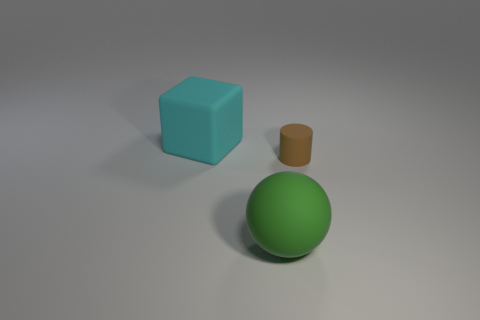Are there an equal number of cyan matte cubes to the right of the tiny matte thing and gray balls?
Keep it short and to the point. Yes. What shape is the matte object that is to the right of the big cube and to the left of the brown cylinder?
Your answer should be very brief. Sphere. Do the green rubber ball and the brown cylinder have the same size?
Your response must be concise. No. Is there a big green cube made of the same material as the green sphere?
Provide a short and direct response. No. What number of big things are both behind the brown matte thing and in front of the brown cylinder?
Offer a very short reply. 0. There is a brown cylinder that is the same material as the large ball; what size is it?
Provide a short and direct response. Small. What number of objects are tiny blue rubber spheres or rubber objects?
Your answer should be compact. 3. What is the color of the big thing left of the big green matte sphere?
Provide a short and direct response. Cyan. What number of objects are either small brown rubber objects that are to the right of the green rubber thing or large matte things behind the ball?
Keep it short and to the point. 2. How big is the matte thing that is in front of the cyan matte cube and behind the large green rubber object?
Provide a short and direct response. Small. 